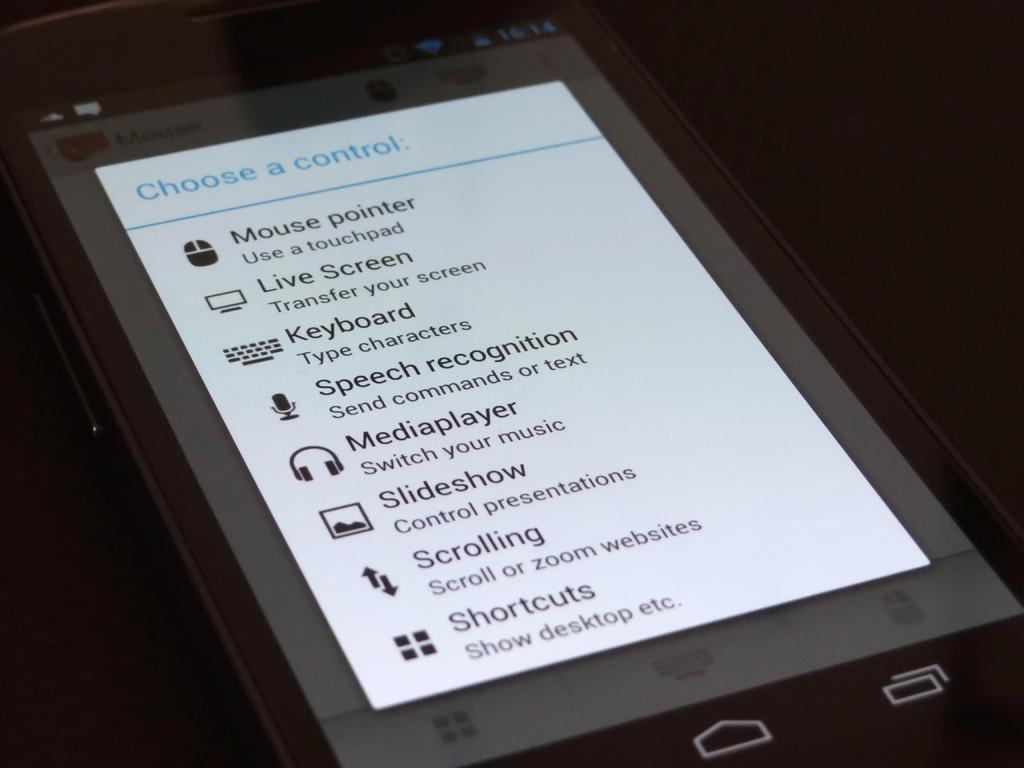What needs to be chosen?
Keep it short and to the point. A control. What is the time on the phone?
Keep it short and to the point. 16:14. 